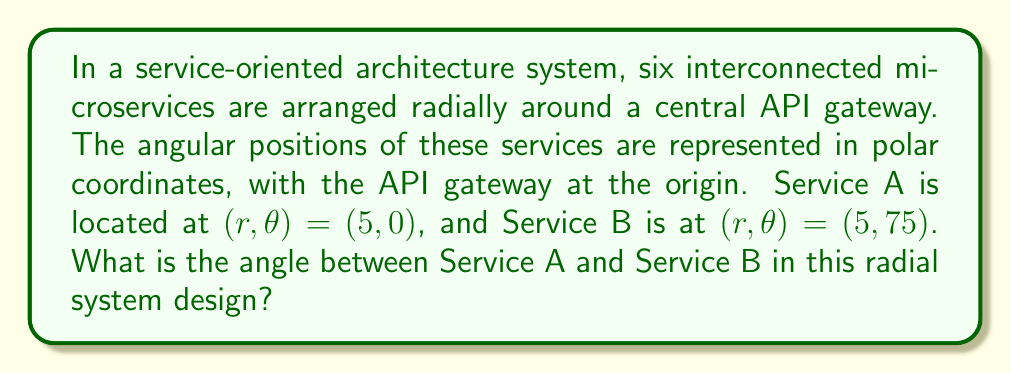Show me your answer to this math problem. To determine the angle between two services in a radial system design, we need to consider their angular positions in polar coordinates. Let's approach this step-by-step:

1. Identify the given information:
   - Service A is at $(r, \theta) = (5, 0°)$
   - Service B is at $(r, \theta) = (5, 75°)$

2. In polar coordinates, the angle between two points is simply the absolute difference between their angular positions.

3. Calculate the angle:
   $$ \text{Angle} = |\theta_B - \theta_A| $$
   $$ \text{Angle} = |75° - 0°| $$
   $$ \text{Angle} = 75° $$

4. Note that the radial distance ($r$) is not relevant for this calculation, as we're only concerned with the angular separation.

[asy]
import geometry;

unitsize(1cm);

draw(circle((0,0),5));
draw((0,0)--(5,0), arrow=Arrow(TeXHead));
draw((0,0)--(5*cos(75),5*sin(75)), arrow=Arrow(TeXHead));

label("API Gateway", (0,0), S);
label("A", (5.2,0));
label("B", (5.2*cos(75),5.2*sin(75)));

draw(arc((0,0),1,0,75), arrow=Arrow(TeXHead));
label("75°", (1.2,0.6));
[/asy]

This diagram illustrates the radial arrangement of services A and B around the central API gateway, with the 75° angle between them clearly marked.
Answer: The angle between Service A and Service B in the radial system design is 75°. 